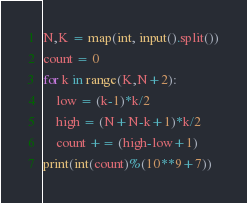<code> <loc_0><loc_0><loc_500><loc_500><_Python_>N,K = map(int, input().split())
count = 0
for k in range(K,N+2):
    low = (k-1)*k/2
    high = (N+N-k+1)*k/2
    count += (high-low+1)
print(int(count)%(10**9+7))</code> 